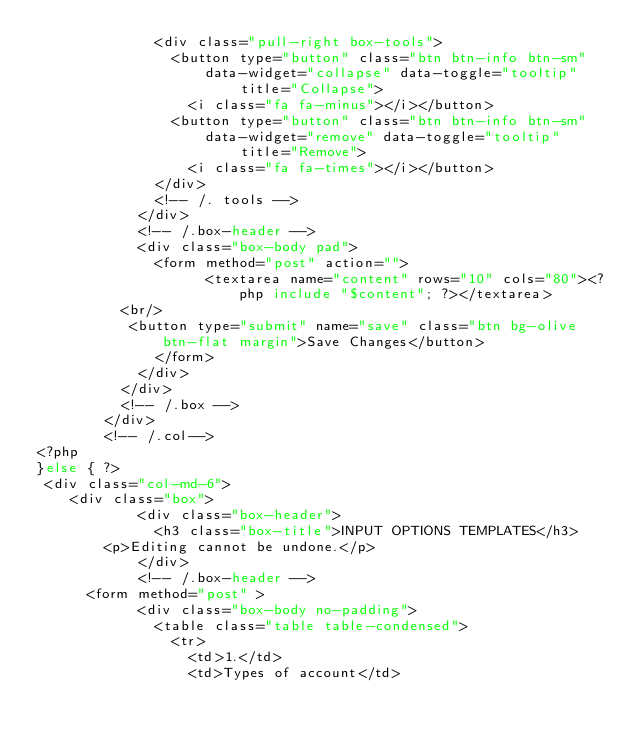Convert code to text. <code><loc_0><loc_0><loc_500><loc_500><_PHP_>              <div class="pull-right box-tools">
                <button type="button" class="btn btn-info btn-sm" data-widget="collapse" data-toggle="tooltip"
                        title="Collapse">
                  <i class="fa fa-minus"></i></button>
                <button type="button" class="btn btn-info btn-sm" data-widget="remove" data-toggle="tooltip"
                        title="Remove">
                  <i class="fa fa-times"></i></button>
              </div>
              <!-- /. tools -->
            </div>
            <!-- /.box-header -->
            <div class="box-body pad">
              <form method="post" action="">
                    <textarea name="content" rows="10" cols="80"><?php include "$content"; ?></textarea>
					<br/>
					 <button type="submit" name="save" class="btn bg-olive btn-flat margin">Save Changes</button>
              </form>
            </div>
          </div>
          <!-- /.box -->
        </div>
        <!-- /.col-->
<?php
}else { ?>
 <div class="col-md-6">
		<div class="box">
            <div class="box-header">
              <h3 class="box-title">INPUT OPTIONS TEMPLATES</h3>
			  <p>Editing cannot be undone.</p>
            </div>
            <!-- /.box-header -->
			<form method="post" >
            <div class="box-body no-padding">
              <table class="table table-condensed">
                <tr>
                  <td>1.</td>
                  <td>Types of account</td></code> 